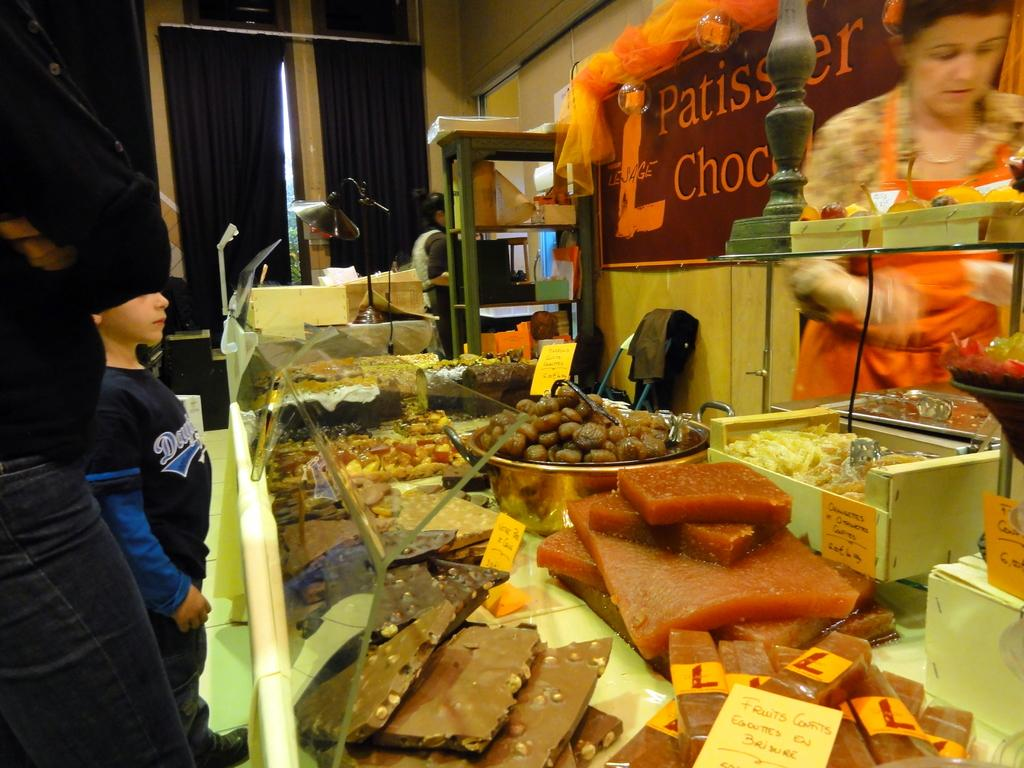<image>
Write a terse but informative summary of the picture. The shop has many treats for sale including fruits confits. 